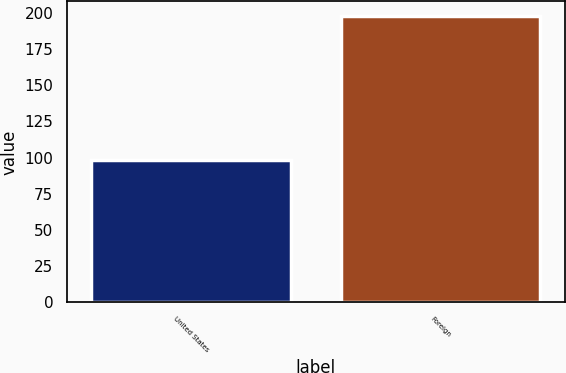Convert chart to OTSL. <chart><loc_0><loc_0><loc_500><loc_500><bar_chart><fcel>United States<fcel>Foreign<nl><fcel>98<fcel>198<nl></chart> 